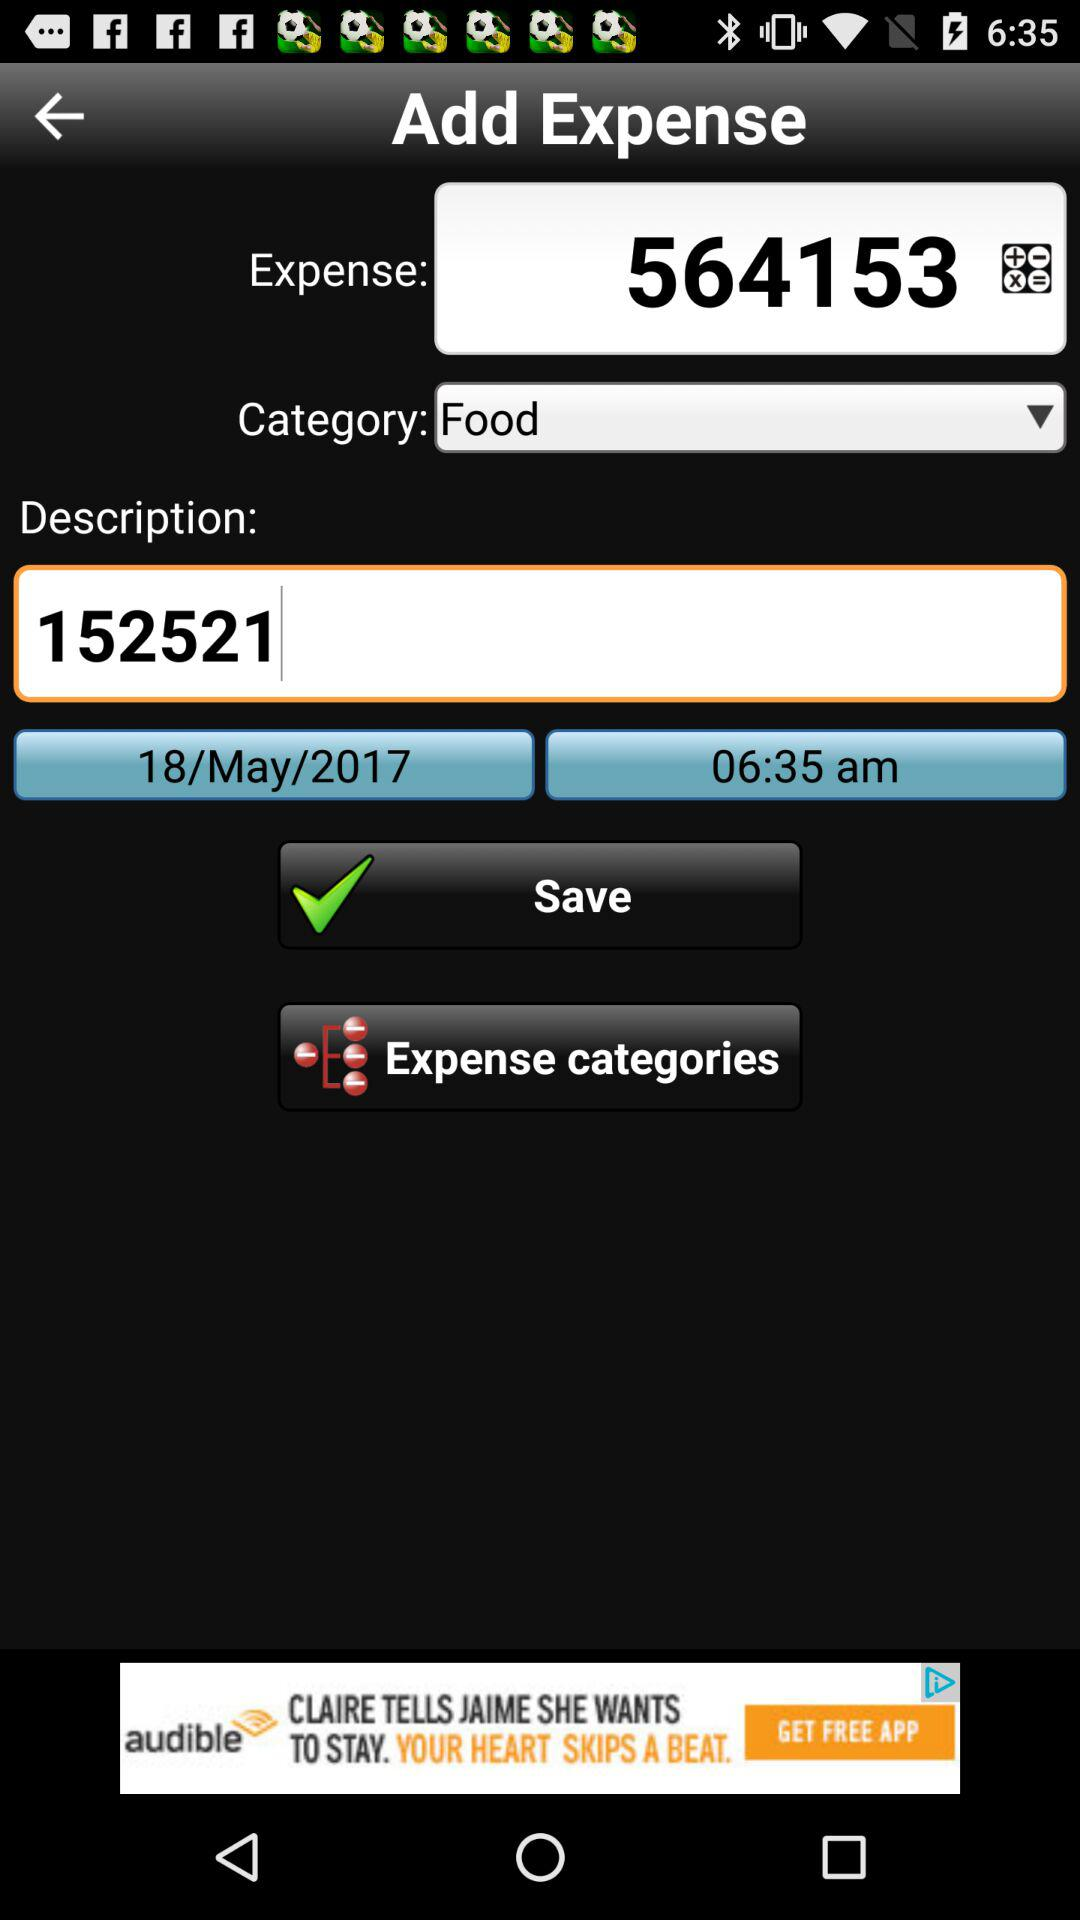What is the expense category?
Answer the question using a single word or phrase. Food 